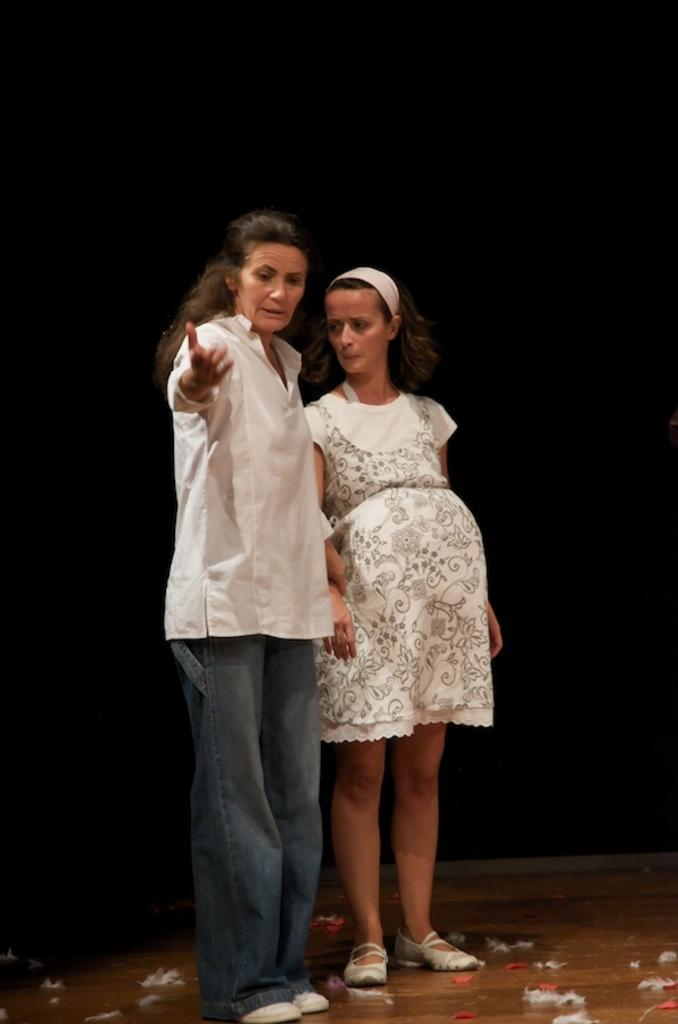How many women are in the image? There are two women in the image. What are the women wearing? Both women are wearing white dresses. What type of snow can be seen falling outside the window in the image? There is no window or snow present in the image; it only features two women wearing white dresses. 